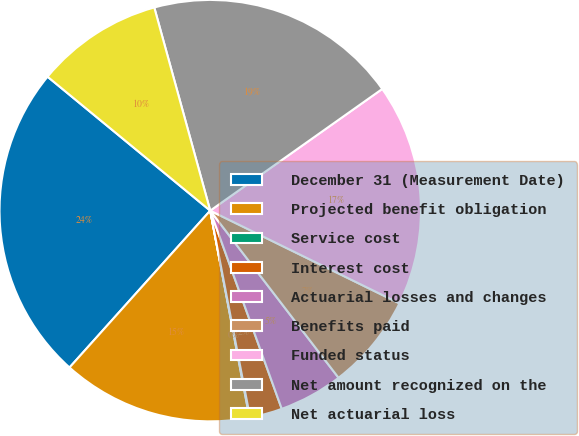<chart> <loc_0><loc_0><loc_500><loc_500><pie_chart><fcel>December 31 (Measurement Date)<fcel>Projected benefit obligation<fcel>Service cost<fcel>Interest cost<fcel>Actuarial losses and changes<fcel>Benefits paid<fcel>Funded status<fcel>Net amount recognized on the<fcel>Net actuarial loss<nl><fcel>24.33%<fcel>14.62%<fcel>0.05%<fcel>2.48%<fcel>4.91%<fcel>7.33%<fcel>17.05%<fcel>19.48%<fcel>9.76%<nl></chart> 